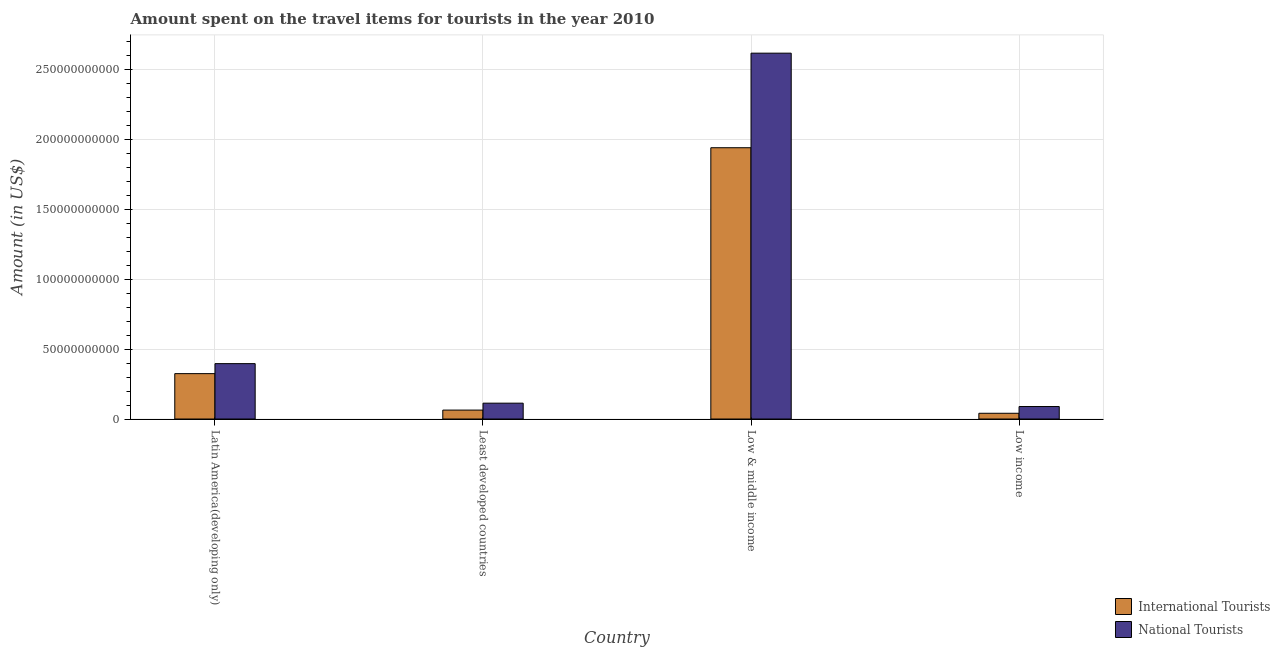How many different coloured bars are there?
Make the answer very short. 2. Are the number of bars on each tick of the X-axis equal?
Ensure brevity in your answer.  Yes. What is the label of the 3rd group of bars from the left?
Make the answer very short. Low & middle income. What is the amount spent on travel items of national tourists in Least developed countries?
Offer a terse response. 1.13e+1. Across all countries, what is the maximum amount spent on travel items of international tourists?
Your answer should be compact. 1.94e+11. Across all countries, what is the minimum amount spent on travel items of international tourists?
Give a very brief answer. 4.11e+09. In which country was the amount spent on travel items of national tourists maximum?
Make the answer very short. Low & middle income. What is the total amount spent on travel items of international tourists in the graph?
Ensure brevity in your answer.  2.37e+11. What is the difference between the amount spent on travel items of international tourists in Latin America(developing only) and that in Least developed countries?
Your answer should be compact. 2.61e+1. What is the difference between the amount spent on travel items of international tourists in Low income and the amount spent on travel items of national tourists in Least developed countries?
Your response must be concise. -7.23e+09. What is the average amount spent on travel items of international tourists per country?
Ensure brevity in your answer.  5.93e+1. What is the difference between the amount spent on travel items of national tourists and amount spent on travel items of international tourists in Least developed countries?
Your answer should be very brief. 4.94e+09. In how many countries, is the amount spent on travel items of international tourists greater than 190000000000 US$?
Provide a short and direct response. 1. What is the ratio of the amount spent on travel items of national tourists in Latin America(developing only) to that in Least developed countries?
Provide a succinct answer. 3.5. Is the amount spent on travel items of national tourists in Latin America(developing only) less than that in Low & middle income?
Offer a terse response. Yes. What is the difference between the highest and the second highest amount spent on travel items of national tourists?
Your answer should be compact. 2.22e+11. What is the difference between the highest and the lowest amount spent on travel items of international tourists?
Give a very brief answer. 1.90e+11. Is the sum of the amount spent on travel items of national tourists in Latin America(developing only) and Least developed countries greater than the maximum amount spent on travel items of international tourists across all countries?
Ensure brevity in your answer.  No. What does the 2nd bar from the left in Least developed countries represents?
Make the answer very short. National Tourists. What does the 1st bar from the right in Low & middle income represents?
Your answer should be compact. National Tourists. How many bars are there?
Your response must be concise. 8. How many countries are there in the graph?
Your answer should be compact. 4. What is the difference between two consecutive major ticks on the Y-axis?
Keep it short and to the point. 5.00e+1. Does the graph contain any zero values?
Your answer should be compact. No. Does the graph contain grids?
Your answer should be compact. Yes. How many legend labels are there?
Make the answer very short. 2. How are the legend labels stacked?
Give a very brief answer. Vertical. What is the title of the graph?
Make the answer very short. Amount spent on the travel items for tourists in the year 2010. Does "Agricultural land" appear as one of the legend labels in the graph?
Make the answer very short. No. What is the label or title of the X-axis?
Give a very brief answer. Country. What is the label or title of the Y-axis?
Keep it short and to the point. Amount (in US$). What is the Amount (in US$) in International Tourists in Latin America(developing only)?
Provide a succinct answer. 3.25e+1. What is the Amount (in US$) of National Tourists in Latin America(developing only)?
Make the answer very short. 3.96e+1. What is the Amount (in US$) of International Tourists in Least developed countries?
Make the answer very short. 6.39e+09. What is the Amount (in US$) in National Tourists in Least developed countries?
Your answer should be compact. 1.13e+1. What is the Amount (in US$) of International Tourists in Low & middle income?
Your answer should be compact. 1.94e+11. What is the Amount (in US$) of National Tourists in Low & middle income?
Your response must be concise. 2.62e+11. What is the Amount (in US$) of International Tourists in Low income?
Your response must be concise. 4.11e+09. What is the Amount (in US$) of National Tourists in Low income?
Make the answer very short. 8.93e+09. Across all countries, what is the maximum Amount (in US$) of International Tourists?
Provide a short and direct response. 1.94e+11. Across all countries, what is the maximum Amount (in US$) in National Tourists?
Make the answer very short. 2.62e+11. Across all countries, what is the minimum Amount (in US$) in International Tourists?
Your answer should be compact. 4.11e+09. Across all countries, what is the minimum Amount (in US$) in National Tourists?
Your response must be concise. 8.93e+09. What is the total Amount (in US$) in International Tourists in the graph?
Offer a terse response. 2.37e+11. What is the total Amount (in US$) of National Tourists in the graph?
Your answer should be very brief. 3.22e+11. What is the difference between the Amount (in US$) of International Tourists in Latin America(developing only) and that in Least developed countries?
Keep it short and to the point. 2.61e+1. What is the difference between the Amount (in US$) in National Tourists in Latin America(developing only) and that in Least developed countries?
Give a very brief answer. 2.83e+1. What is the difference between the Amount (in US$) of International Tourists in Latin America(developing only) and that in Low & middle income?
Keep it short and to the point. -1.62e+11. What is the difference between the Amount (in US$) of National Tourists in Latin America(developing only) and that in Low & middle income?
Make the answer very short. -2.22e+11. What is the difference between the Amount (in US$) in International Tourists in Latin America(developing only) and that in Low income?
Provide a short and direct response. 2.84e+1. What is the difference between the Amount (in US$) of National Tourists in Latin America(developing only) and that in Low income?
Provide a succinct answer. 3.07e+1. What is the difference between the Amount (in US$) of International Tourists in Least developed countries and that in Low & middle income?
Provide a succinct answer. -1.88e+11. What is the difference between the Amount (in US$) of National Tourists in Least developed countries and that in Low & middle income?
Provide a succinct answer. -2.50e+11. What is the difference between the Amount (in US$) of International Tourists in Least developed countries and that in Low income?
Make the answer very short. 2.29e+09. What is the difference between the Amount (in US$) of National Tourists in Least developed countries and that in Low income?
Offer a terse response. 2.40e+09. What is the difference between the Amount (in US$) of International Tourists in Low & middle income and that in Low income?
Provide a succinct answer. 1.90e+11. What is the difference between the Amount (in US$) of National Tourists in Low & middle income and that in Low income?
Make the answer very short. 2.53e+11. What is the difference between the Amount (in US$) in International Tourists in Latin America(developing only) and the Amount (in US$) in National Tourists in Least developed countries?
Give a very brief answer. 2.11e+1. What is the difference between the Amount (in US$) of International Tourists in Latin America(developing only) and the Amount (in US$) of National Tourists in Low & middle income?
Offer a very short reply. -2.29e+11. What is the difference between the Amount (in US$) of International Tourists in Latin America(developing only) and the Amount (in US$) of National Tourists in Low income?
Your response must be concise. 2.35e+1. What is the difference between the Amount (in US$) of International Tourists in Least developed countries and the Amount (in US$) of National Tourists in Low & middle income?
Ensure brevity in your answer.  -2.55e+11. What is the difference between the Amount (in US$) of International Tourists in Least developed countries and the Amount (in US$) of National Tourists in Low income?
Ensure brevity in your answer.  -2.54e+09. What is the difference between the Amount (in US$) of International Tourists in Low & middle income and the Amount (in US$) of National Tourists in Low income?
Ensure brevity in your answer.  1.85e+11. What is the average Amount (in US$) in International Tourists per country?
Your answer should be very brief. 5.93e+1. What is the average Amount (in US$) of National Tourists per country?
Provide a succinct answer. 8.04e+1. What is the difference between the Amount (in US$) of International Tourists and Amount (in US$) of National Tourists in Latin America(developing only)?
Offer a terse response. -7.16e+09. What is the difference between the Amount (in US$) in International Tourists and Amount (in US$) in National Tourists in Least developed countries?
Ensure brevity in your answer.  -4.94e+09. What is the difference between the Amount (in US$) of International Tourists and Amount (in US$) of National Tourists in Low & middle income?
Ensure brevity in your answer.  -6.76e+1. What is the difference between the Amount (in US$) in International Tourists and Amount (in US$) in National Tourists in Low income?
Give a very brief answer. -4.83e+09. What is the ratio of the Amount (in US$) of International Tourists in Latin America(developing only) to that in Least developed countries?
Provide a succinct answer. 5.08. What is the ratio of the Amount (in US$) of National Tourists in Latin America(developing only) to that in Least developed countries?
Ensure brevity in your answer.  3.5. What is the ratio of the Amount (in US$) of International Tourists in Latin America(developing only) to that in Low & middle income?
Ensure brevity in your answer.  0.17. What is the ratio of the Amount (in US$) of National Tourists in Latin America(developing only) to that in Low & middle income?
Your response must be concise. 0.15. What is the ratio of the Amount (in US$) in International Tourists in Latin America(developing only) to that in Low income?
Provide a succinct answer. 7.9. What is the ratio of the Amount (in US$) of National Tourists in Latin America(developing only) to that in Low income?
Your answer should be compact. 4.44. What is the ratio of the Amount (in US$) in International Tourists in Least developed countries to that in Low & middle income?
Your response must be concise. 0.03. What is the ratio of the Amount (in US$) of National Tourists in Least developed countries to that in Low & middle income?
Ensure brevity in your answer.  0.04. What is the ratio of the Amount (in US$) in International Tourists in Least developed countries to that in Low income?
Provide a short and direct response. 1.56. What is the ratio of the Amount (in US$) of National Tourists in Least developed countries to that in Low income?
Make the answer very short. 1.27. What is the ratio of the Amount (in US$) of International Tourists in Low & middle income to that in Low income?
Offer a terse response. 47.25. What is the ratio of the Amount (in US$) in National Tourists in Low & middle income to that in Low income?
Offer a terse response. 29.3. What is the difference between the highest and the second highest Amount (in US$) in International Tourists?
Give a very brief answer. 1.62e+11. What is the difference between the highest and the second highest Amount (in US$) of National Tourists?
Offer a very short reply. 2.22e+11. What is the difference between the highest and the lowest Amount (in US$) in International Tourists?
Keep it short and to the point. 1.90e+11. What is the difference between the highest and the lowest Amount (in US$) in National Tourists?
Keep it short and to the point. 2.53e+11. 